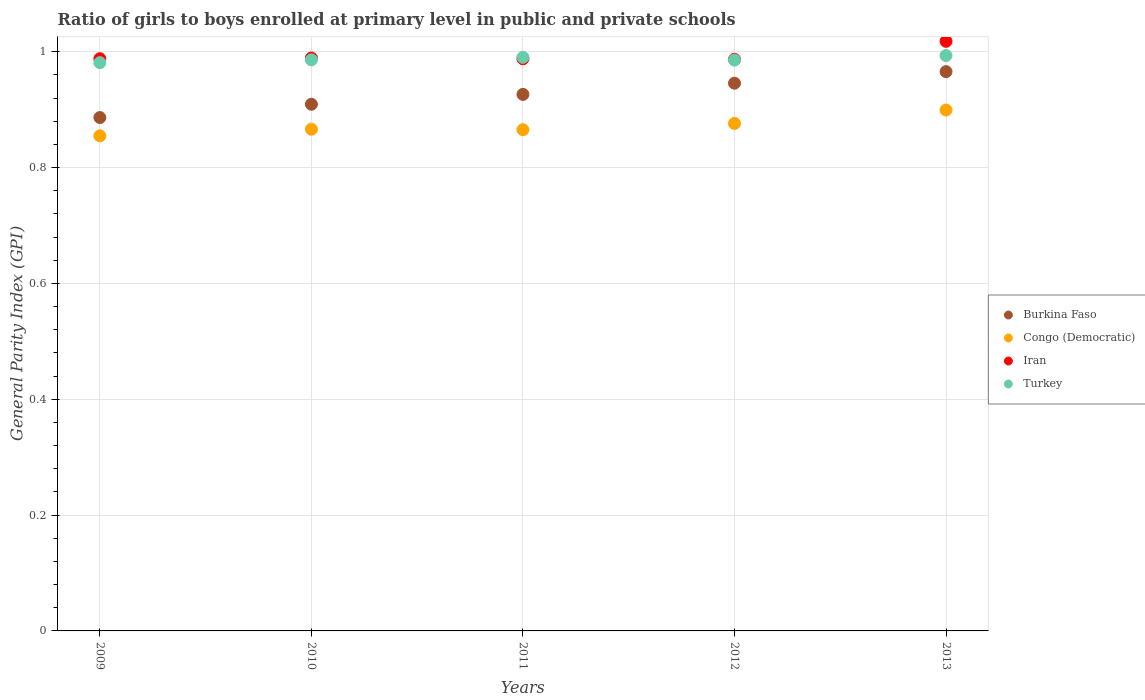How many different coloured dotlines are there?
Offer a very short reply. 4. Is the number of dotlines equal to the number of legend labels?
Provide a succinct answer. Yes. What is the general parity index in Congo (Democratic) in 2011?
Offer a terse response. 0.87. Across all years, what is the maximum general parity index in Turkey?
Your answer should be compact. 0.99. Across all years, what is the minimum general parity index in Burkina Faso?
Offer a terse response. 0.89. In which year was the general parity index in Congo (Democratic) maximum?
Offer a terse response. 2013. In which year was the general parity index in Congo (Democratic) minimum?
Your answer should be very brief. 2009. What is the total general parity index in Congo (Democratic) in the graph?
Offer a terse response. 4.36. What is the difference between the general parity index in Burkina Faso in 2010 and that in 2011?
Give a very brief answer. -0.02. What is the difference between the general parity index in Congo (Democratic) in 2013 and the general parity index in Burkina Faso in 2010?
Provide a succinct answer. -0.01. What is the average general parity index in Turkey per year?
Your answer should be very brief. 0.99. In the year 2012, what is the difference between the general parity index in Iran and general parity index in Burkina Faso?
Your response must be concise. 0.04. What is the ratio of the general parity index in Congo (Democratic) in 2009 to that in 2012?
Offer a very short reply. 0.98. Is the difference between the general parity index in Iran in 2011 and 2012 greater than the difference between the general parity index in Burkina Faso in 2011 and 2012?
Your answer should be compact. Yes. What is the difference between the highest and the second highest general parity index in Burkina Faso?
Your answer should be very brief. 0.02. What is the difference between the highest and the lowest general parity index in Turkey?
Your answer should be compact. 0.01. Is the sum of the general parity index in Iran in 2009 and 2010 greater than the maximum general parity index in Turkey across all years?
Make the answer very short. Yes. Is it the case that in every year, the sum of the general parity index in Turkey and general parity index in Burkina Faso  is greater than the sum of general parity index in Iran and general parity index in Congo (Democratic)?
Ensure brevity in your answer.  No. Is it the case that in every year, the sum of the general parity index in Iran and general parity index in Congo (Democratic)  is greater than the general parity index in Burkina Faso?
Your answer should be compact. Yes. Is the general parity index in Iran strictly greater than the general parity index in Burkina Faso over the years?
Ensure brevity in your answer.  Yes. Is the general parity index in Burkina Faso strictly less than the general parity index in Iran over the years?
Provide a succinct answer. Yes. How many dotlines are there?
Make the answer very short. 4. How many years are there in the graph?
Your response must be concise. 5. Does the graph contain any zero values?
Your response must be concise. No. Does the graph contain grids?
Your answer should be compact. Yes. How many legend labels are there?
Offer a terse response. 4. What is the title of the graph?
Give a very brief answer. Ratio of girls to boys enrolled at primary level in public and private schools. What is the label or title of the Y-axis?
Your answer should be compact. General Parity Index (GPI). What is the General Parity Index (GPI) of Burkina Faso in 2009?
Keep it short and to the point. 0.89. What is the General Parity Index (GPI) of Congo (Democratic) in 2009?
Your answer should be compact. 0.85. What is the General Parity Index (GPI) in Iran in 2009?
Offer a very short reply. 0.99. What is the General Parity Index (GPI) of Turkey in 2009?
Make the answer very short. 0.98. What is the General Parity Index (GPI) of Burkina Faso in 2010?
Make the answer very short. 0.91. What is the General Parity Index (GPI) of Congo (Democratic) in 2010?
Provide a succinct answer. 0.87. What is the General Parity Index (GPI) of Iran in 2010?
Your response must be concise. 0.99. What is the General Parity Index (GPI) in Turkey in 2010?
Keep it short and to the point. 0.99. What is the General Parity Index (GPI) in Burkina Faso in 2011?
Offer a very short reply. 0.93. What is the General Parity Index (GPI) of Congo (Democratic) in 2011?
Ensure brevity in your answer.  0.87. What is the General Parity Index (GPI) of Iran in 2011?
Provide a short and direct response. 0.99. What is the General Parity Index (GPI) in Turkey in 2011?
Offer a very short reply. 0.99. What is the General Parity Index (GPI) in Burkina Faso in 2012?
Your response must be concise. 0.95. What is the General Parity Index (GPI) in Congo (Democratic) in 2012?
Offer a very short reply. 0.88. What is the General Parity Index (GPI) of Iran in 2012?
Your answer should be very brief. 0.99. What is the General Parity Index (GPI) in Turkey in 2012?
Offer a terse response. 0.99. What is the General Parity Index (GPI) in Burkina Faso in 2013?
Provide a succinct answer. 0.97. What is the General Parity Index (GPI) in Congo (Democratic) in 2013?
Your response must be concise. 0.9. What is the General Parity Index (GPI) in Iran in 2013?
Offer a terse response. 1.02. What is the General Parity Index (GPI) in Turkey in 2013?
Keep it short and to the point. 0.99. Across all years, what is the maximum General Parity Index (GPI) of Burkina Faso?
Ensure brevity in your answer.  0.97. Across all years, what is the maximum General Parity Index (GPI) of Congo (Democratic)?
Provide a succinct answer. 0.9. Across all years, what is the maximum General Parity Index (GPI) in Iran?
Make the answer very short. 1.02. Across all years, what is the maximum General Parity Index (GPI) in Turkey?
Offer a very short reply. 0.99. Across all years, what is the minimum General Parity Index (GPI) in Burkina Faso?
Ensure brevity in your answer.  0.89. Across all years, what is the minimum General Parity Index (GPI) of Congo (Democratic)?
Your response must be concise. 0.85. Across all years, what is the minimum General Parity Index (GPI) in Iran?
Your answer should be very brief. 0.99. Across all years, what is the minimum General Parity Index (GPI) in Turkey?
Ensure brevity in your answer.  0.98. What is the total General Parity Index (GPI) of Burkina Faso in the graph?
Your response must be concise. 4.63. What is the total General Parity Index (GPI) of Congo (Democratic) in the graph?
Give a very brief answer. 4.36. What is the total General Parity Index (GPI) in Iran in the graph?
Your answer should be very brief. 4.97. What is the total General Parity Index (GPI) in Turkey in the graph?
Provide a short and direct response. 4.94. What is the difference between the General Parity Index (GPI) of Burkina Faso in 2009 and that in 2010?
Provide a short and direct response. -0.02. What is the difference between the General Parity Index (GPI) in Congo (Democratic) in 2009 and that in 2010?
Make the answer very short. -0.01. What is the difference between the General Parity Index (GPI) in Iran in 2009 and that in 2010?
Keep it short and to the point. -0. What is the difference between the General Parity Index (GPI) in Turkey in 2009 and that in 2010?
Provide a short and direct response. -0. What is the difference between the General Parity Index (GPI) in Burkina Faso in 2009 and that in 2011?
Offer a terse response. -0.04. What is the difference between the General Parity Index (GPI) in Congo (Democratic) in 2009 and that in 2011?
Your response must be concise. -0.01. What is the difference between the General Parity Index (GPI) of Turkey in 2009 and that in 2011?
Give a very brief answer. -0.01. What is the difference between the General Parity Index (GPI) of Burkina Faso in 2009 and that in 2012?
Make the answer very short. -0.06. What is the difference between the General Parity Index (GPI) of Congo (Democratic) in 2009 and that in 2012?
Your response must be concise. -0.02. What is the difference between the General Parity Index (GPI) in Iran in 2009 and that in 2012?
Offer a very short reply. 0. What is the difference between the General Parity Index (GPI) of Turkey in 2009 and that in 2012?
Make the answer very short. -0. What is the difference between the General Parity Index (GPI) of Burkina Faso in 2009 and that in 2013?
Ensure brevity in your answer.  -0.08. What is the difference between the General Parity Index (GPI) in Congo (Democratic) in 2009 and that in 2013?
Ensure brevity in your answer.  -0.04. What is the difference between the General Parity Index (GPI) in Iran in 2009 and that in 2013?
Ensure brevity in your answer.  -0.03. What is the difference between the General Parity Index (GPI) in Turkey in 2009 and that in 2013?
Your answer should be compact. -0.01. What is the difference between the General Parity Index (GPI) of Burkina Faso in 2010 and that in 2011?
Keep it short and to the point. -0.02. What is the difference between the General Parity Index (GPI) of Congo (Democratic) in 2010 and that in 2011?
Your response must be concise. 0. What is the difference between the General Parity Index (GPI) of Iran in 2010 and that in 2011?
Ensure brevity in your answer.  0. What is the difference between the General Parity Index (GPI) in Turkey in 2010 and that in 2011?
Offer a terse response. -0. What is the difference between the General Parity Index (GPI) in Burkina Faso in 2010 and that in 2012?
Provide a succinct answer. -0.04. What is the difference between the General Parity Index (GPI) of Congo (Democratic) in 2010 and that in 2012?
Provide a succinct answer. -0.01. What is the difference between the General Parity Index (GPI) of Iran in 2010 and that in 2012?
Your response must be concise. 0. What is the difference between the General Parity Index (GPI) in Burkina Faso in 2010 and that in 2013?
Provide a short and direct response. -0.06. What is the difference between the General Parity Index (GPI) of Congo (Democratic) in 2010 and that in 2013?
Provide a succinct answer. -0.03. What is the difference between the General Parity Index (GPI) in Iran in 2010 and that in 2013?
Ensure brevity in your answer.  -0.03. What is the difference between the General Parity Index (GPI) in Turkey in 2010 and that in 2013?
Provide a succinct answer. -0.01. What is the difference between the General Parity Index (GPI) in Burkina Faso in 2011 and that in 2012?
Make the answer very short. -0.02. What is the difference between the General Parity Index (GPI) of Congo (Democratic) in 2011 and that in 2012?
Provide a short and direct response. -0.01. What is the difference between the General Parity Index (GPI) in Iran in 2011 and that in 2012?
Your response must be concise. 0. What is the difference between the General Parity Index (GPI) in Turkey in 2011 and that in 2012?
Ensure brevity in your answer.  0. What is the difference between the General Parity Index (GPI) in Burkina Faso in 2011 and that in 2013?
Your answer should be very brief. -0.04. What is the difference between the General Parity Index (GPI) in Congo (Democratic) in 2011 and that in 2013?
Provide a short and direct response. -0.03. What is the difference between the General Parity Index (GPI) in Iran in 2011 and that in 2013?
Give a very brief answer. -0.03. What is the difference between the General Parity Index (GPI) of Turkey in 2011 and that in 2013?
Your answer should be very brief. -0. What is the difference between the General Parity Index (GPI) of Burkina Faso in 2012 and that in 2013?
Ensure brevity in your answer.  -0.02. What is the difference between the General Parity Index (GPI) in Congo (Democratic) in 2012 and that in 2013?
Give a very brief answer. -0.02. What is the difference between the General Parity Index (GPI) in Iran in 2012 and that in 2013?
Give a very brief answer. -0.03. What is the difference between the General Parity Index (GPI) of Turkey in 2012 and that in 2013?
Offer a terse response. -0.01. What is the difference between the General Parity Index (GPI) of Burkina Faso in 2009 and the General Parity Index (GPI) of Congo (Democratic) in 2010?
Your answer should be very brief. 0.02. What is the difference between the General Parity Index (GPI) in Burkina Faso in 2009 and the General Parity Index (GPI) in Iran in 2010?
Make the answer very short. -0.1. What is the difference between the General Parity Index (GPI) of Burkina Faso in 2009 and the General Parity Index (GPI) of Turkey in 2010?
Your answer should be very brief. -0.1. What is the difference between the General Parity Index (GPI) in Congo (Democratic) in 2009 and the General Parity Index (GPI) in Iran in 2010?
Your answer should be compact. -0.13. What is the difference between the General Parity Index (GPI) in Congo (Democratic) in 2009 and the General Parity Index (GPI) in Turkey in 2010?
Your answer should be very brief. -0.13. What is the difference between the General Parity Index (GPI) of Iran in 2009 and the General Parity Index (GPI) of Turkey in 2010?
Ensure brevity in your answer.  0. What is the difference between the General Parity Index (GPI) of Burkina Faso in 2009 and the General Parity Index (GPI) of Congo (Democratic) in 2011?
Give a very brief answer. 0.02. What is the difference between the General Parity Index (GPI) in Burkina Faso in 2009 and the General Parity Index (GPI) in Iran in 2011?
Offer a terse response. -0.1. What is the difference between the General Parity Index (GPI) of Burkina Faso in 2009 and the General Parity Index (GPI) of Turkey in 2011?
Give a very brief answer. -0.1. What is the difference between the General Parity Index (GPI) of Congo (Democratic) in 2009 and the General Parity Index (GPI) of Iran in 2011?
Give a very brief answer. -0.13. What is the difference between the General Parity Index (GPI) in Congo (Democratic) in 2009 and the General Parity Index (GPI) in Turkey in 2011?
Ensure brevity in your answer.  -0.14. What is the difference between the General Parity Index (GPI) in Iran in 2009 and the General Parity Index (GPI) in Turkey in 2011?
Offer a terse response. -0. What is the difference between the General Parity Index (GPI) of Burkina Faso in 2009 and the General Parity Index (GPI) of Congo (Democratic) in 2012?
Your response must be concise. 0.01. What is the difference between the General Parity Index (GPI) of Burkina Faso in 2009 and the General Parity Index (GPI) of Iran in 2012?
Provide a short and direct response. -0.1. What is the difference between the General Parity Index (GPI) in Burkina Faso in 2009 and the General Parity Index (GPI) in Turkey in 2012?
Keep it short and to the point. -0.1. What is the difference between the General Parity Index (GPI) in Congo (Democratic) in 2009 and the General Parity Index (GPI) in Iran in 2012?
Your answer should be compact. -0.13. What is the difference between the General Parity Index (GPI) of Congo (Democratic) in 2009 and the General Parity Index (GPI) of Turkey in 2012?
Provide a succinct answer. -0.13. What is the difference between the General Parity Index (GPI) in Iran in 2009 and the General Parity Index (GPI) in Turkey in 2012?
Offer a terse response. 0. What is the difference between the General Parity Index (GPI) in Burkina Faso in 2009 and the General Parity Index (GPI) in Congo (Democratic) in 2013?
Make the answer very short. -0.01. What is the difference between the General Parity Index (GPI) of Burkina Faso in 2009 and the General Parity Index (GPI) of Iran in 2013?
Provide a succinct answer. -0.13. What is the difference between the General Parity Index (GPI) in Burkina Faso in 2009 and the General Parity Index (GPI) in Turkey in 2013?
Make the answer very short. -0.11. What is the difference between the General Parity Index (GPI) in Congo (Democratic) in 2009 and the General Parity Index (GPI) in Iran in 2013?
Keep it short and to the point. -0.16. What is the difference between the General Parity Index (GPI) in Congo (Democratic) in 2009 and the General Parity Index (GPI) in Turkey in 2013?
Provide a short and direct response. -0.14. What is the difference between the General Parity Index (GPI) of Iran in 2009 and the General Parity Index (GPI) of Turkey in 2013?
Offer a terse response. -0.01. What is the difference between the General Parity Index (GPI) of Burkina Faso in 2010 and the General Parity Index (GPI) of Congo (Democratic) in 2011?
Offer a very short reply. 0.04. What is the difference between the General Parity Index (GPI) of Burkina Faso in 2010 and the General Parity Index (GPI) of Iran in 2011?
Your response must be concise. -0.08. What is the difference between the General Parity Index (GPI) of Burkina Faso in 2010 and the General Parity Index (GPI) of Turkey in 2011?
Provide a succinct answer. -0.08. What is the difference between the General Parity Index (GPI) of Congo (Democratic) in 2010 and the General Parity Index (GPI) of Iran in 2011?
Your answer should be compact. -0.12. What is the difference between the General Parity Index (GPI) in Congo (Democratic) in 2010 and the General Parity Index (GPI) in Turkey in 2011?
Make the answer very short. -0.12. What is the difference between the General Parity Index (GPI) in Iran in 2010 and the General Parity Index (GPI) in Turkey in 2011?
Ensure brevity in your answer.  -0. What is the difference between the General Parity Index (GPI) of Burkina Faso in 2010 and the General Parity Index (GPI) of Congo (Democratic) in 2012?
Your answer should be very brief. 0.03. What is the difference between the General Parity Index (GPI) in Burkina Faso in 2010 and the General Parity Index (GPI) in Iran in 2012?
Ensure brevity in your answer.  -0.08. What is the difference between the General Parity Index (GPI) of Burkina Faso in 2010 and the General Parity Index (GPI) of Turkey in 2012?
Make the answer very short. -0.08. What is the difference between the General Parity Index (GPI) of Congo (Democratic) in 2010 and the General Parity Index (GPI) of Iran in 2012?
Ensure brevity in your answer.  -0.12. What is the difference between the General Parity Index (GPI) in Congo (Democratic) in 2010 and the General Parity Index (GPI) in Turkey in 2012?
Your answer should be compact. -0.12. What is the difference between the General Parity Index (GPI) of Iran in 2010 and the General Parity Index (GPI) of Turkey in 2012?
Provide a short and direct response. 0. What is the difference between the General Parity Index (GPI) in Burkina Faso in 2010 and the General Parity Index (GPI) in Congo (Democratic) in 2013?
Offer a very short reply. 0.01. What is the difference between the General Parity Index (GPI) in Burkina Faso in 2010 and the General Parity Index (GPI) in Iran in 2013?
Offer a terse response. -0.11. What is the difference between the General Parity Index (GPI) in Burkina Faso in 2010 and the General Parity Index (GPI) in Turkey in 2013?
Your answer should be compact. -0.08. What is the difference between the General Parity Index (GPI) of Congo (Democratic) in 2010 and the General Parity Index (GPI) of Iran in 2013?
Your answer should be compact. -0.15. What is the difference between the General Parity Index (GPI) in Congo (Democratic) in 2010 and the General Parity Index (GPI) in Turkey in 2013?
Ensure brevity in your answer.  -0.13. What is the difference between the General Parity Index (GPI) of Iran in 2010 and the General Parity Index (GPI) of Turkey in 2013?
Offer a very short reply. -0. What is the difference between the General Parity Index (GPI) in Burkina Faso in 2011 and the General Parity Index (GPI) in Congo (Democratic) in 2012?
Provide a short and direct response. 0.05. What is the difference between the General Parity Index (GPI) of Burkina Faso in 2011 and the General Parity Index (GPI) of Iran in 2012?
Ensure brevity in your answer.  -0.06. What is the difference between the General Parity Index (GPI) of Burkina Faso in 2011 and the General Parity Index (GPI) of Turkey in 2012?
Ensure brevity in your answer.  -0.06. What is the difference between the General Parity Index (GPI) in Congo (Democratic) in 2011 and the General Parity Index (GPI) in Iran in 2012?
Provide a succinct answer. -0.12. What is the difference between the General Parity Index (GPI) in Congo (Democratic) in 2011 and the General Parity Index (GPI) in Turkey in 2012?
Offer a very short reply. -0.12. What is the difference between the General Parity Index (GPI) in Iran in 2011 and the General Parity Index (GPI) in Turkey in 2012?
Offer a very short reply. 0. What is the difference between the General Parity Index (GPI) in Burkina Faso in 2011 and the General Parity Index (GPI) in Congo (Democratic) in 2013?
Give a very brief answer. 0.03. What is the difference between the General Parity Index (GPI) of Burkina Faso in 2011 and the General Parity Index (GPI) of Iran in 2013?
Offer a very short reply. -0.09. What is the difference between the General Parity Index (GPI) of Burkina Faso in 2011 and the General Parity Index (GPI) of Turkey in 2013?
Provide a succinct answer. -0.07. What is the difference between the General Parity Index (GPI) of Congo (Democratic) in 2011 and the General Parity Index (GPI) of Iran in 2013?
Your response must be concise. -0.15. What is the difference between the General Parity Index (GPI) of Congo (Democratic) in 2011 and the General Parity Index (GPI) of Turkey in 2013?
Your answer should be compact. -0.13. What is the difference between the General Parity Index (GPI) in Iran in 2011 and the General Parity Index (GPI) in Turkey in 2013?
Offer a terse response. -0.01. What is the difference between the General Parity Index (GPI) in Burkina Faso in 2012 and the General Parity Index (GPI) in Congo (Democratic) in 2013?
Provide a short and direct response. 0.05. What is the difference between the General Parity Index (GPI) in Burkina Faso in 2012 and the General Parity Index (GPI) in Iran in 2013?
Your answer should be compact. -0.07. What is the difference between the General Parity Index (GPI) in Burkina Faso in 2012 and the General Parity Index (GPI) in Turkey in 2013?
Give a very brief answer. -0.05. What is the difference between the General Parity Index (GPI) of Congo (Democratic) in 2012 and the General Parity Index (GPI) of Iran in 2013?
Keep it short and to the point. -0.14. What is the difference between the General Parity Index (GPI) in Congo (Democratic) in 2012 and the General Parity Index (GPI) in Turkey in 2013?
Provide a short and direct response. -0.12. What is the difference between the General Parity Index (GPI) in Iran in 2012 and the General Parity Index (GPI) in Turkey in 2013?
Give a very brief answer. -0.01. What is the average General Parity Index (GPI) of Burkina Faso per year?
Offer a terse response. 0.93. What is the average General Parity Index (GPI) in Congo (Democratic) per year?
Make the answer very short. 0.87. What is the average General Parity Index (GPI) of Iran per year?
Make the answer very short. 0.99. What is the average General Parity Index (GPI) in Turkey per year?
Provide a short and direct response. 0.99. In the year 2009, what is the difference between the General Parity Index (GPI) in Burkina Faso and General Parity Index (GPI) in Congo (Democratic)?
Give a very brief answer. 0.03. In the year 2009, what is the difference between the General Parity Index (GPI) in Burkina Faso and General Parity Index (GPI) in Iran?
Offer a terse response. -0.1. In the year 2009, what is the difference between the General Parity Index (GPI) of Burkina Faso and General Parity Index (GPI) of Turkey?
Your answer should be compact. -0.09. In the year 2009, what is the difference between the General Parity Index (GPI) in Congo (Democratic) and General Parity Index (GPI) in Iran?
Your answer should be compact. -0.13. In the year 2009, what is the difference between the General Parity Index (GPI) of Congo (Democratic) and General Parity Index (GPI) of Turkey?
Ensure brevity in your answer.  -0.13. In the year 2009, what is the difference between the General Parity Index (GPI) in Iran and General Parity Index (GPI) in Turkey?
Keep it short and to the point. 0.01. In the year 2010, what is the difference between the General Parity Index (GPI) in Burkina Faso and General Parity Index (GPI) in Congo (Democratic)?
Make the answer very short. 0.04. In the year 2010, what is the difference between the General Parity Index (GPI) in Burkina Faso and General Parity Index (GPI) in Iran?
Offer a very short reply. -0.08. In the year 2010, what is the difference between the General Parity Index (GPI) of Burkina Faso and General Parity Index (GPI) of Turkey?
Your answer should be very brief. -0.08. In the year 2010, what is the difference between the General Parity Index (GPI) in Congo (Democratic) and General Parity Index (GPI) in Iran?
Provide a succinct answer. -0.12. In the year 2010, what is the difference between the General Parity Index (GPI) in Congo (Democratic) and General Parity Index (GPI) in Turkey?
Keep it short and to the point. -0.12. In the year 2010, what is the difference between the General Parity Index (GPI) of Iran and General Parity Index (GPI) of Turkey?
Ensure brevity in your answer.  0. In the year 2011, what is the difference between the General Parity Index (GPI) of Burkina Faso and General Parity Index (GPI) of Congo (Democratic)?
Your response must be concise. 0.06. In the year 2011, what is the difference between the General Parity Index (GPI) of Burkina Faso and General Parity Index (GPI) of Iran?
Give a very brief answer. -0.06. In the year 2011, what is the difference between the General Parity Index (GPI) in Burkina Faso and General Parity Index (GPI) in Turkey?
Offer a very short reply. -0.06. In the year 2011, what is the difference between the General Parity Index (GPI) in Congo (Democratic) and General Parity Index (GPI) in Iran?
Provide a succinct answer. -0.12. In the year 2011, what is the difference between the General Parity Index (GPI) of Congo (Democratic) and General Parity Index (GPI) of Turkey?
Ensure brevity in your answer.  -0.12. In the year 2011, what is the difference between the General Parity Index (GPI) in Iran and General Parity Index (GPI) in Turkey?
Keep it short and to the point. -0. In the year 2012, what is the difference between the General Parity Index (GPI) of Burkina Faso and General Parity Index (GPI) of Congo (Democratic)?
Offer a terse response. 0.07. In the year 2012, what is the difference between the General Parity Index (GPI) of Burkina Faso and General Parity Index (GPI) of Iran?
Offer a terse response. -0.04. In the year 2012, what is the difference between the General Parity Index (GPI) in Burkina Faso and General Parity Index (GPI) in Turkey?
Offer a very short reply. -0.04. In the year 2012, what is the difference between the General Parity Index (GPI) of Congo (Democratic) and General Parity Index (GPI) of Iran?
Offer a terse response. -0.11. In the year 2012, what is the difference between the General Parity Index (GPI) in Congo (Democratic) and General Parity Index (GPI) in Turkey?
Your answer should be compact. -0.11. In the year 2012, what is the difference between the General Parity Index (GPI) in Iran and General Parity Index (GPI) in Turkey?
Offer a terse response. 0. In the year 2013, what is the difference between the General Parity Index (GPI) of Burkina Faso and General Parity Index (GPI) of Congo (Democratic)?
Offer a terse response. 0.07. In the year 2013, what is the difference between the General Parity Index (GPI) of Burkina Faso and General Parity Index (GPI) of Iran?
Give a very brief answer. -0.05. In the year 2013, what is the difference between the General Parity Index (GPI) of Burkina Faso and General Parity Index (GPI) of Turkey?
Provide a succinct answer. -0.03. In the year 2013, what is the difference between the General Parity Index (GPI) of Congo (Democratic) and General Parity Index (GPI) of Iran?
Offer a very short reply. -0.12. In the year 2013, what is the difference between the General Parity Index (GPI) in Congo (Democratic) and General Parity Index (GPI) in Turkey?
Keep it short and to the point. -0.09. In the year 2013, what is the difference between the General Parity Index (GPI) in Iran and General Parity Index (GPI) in Turkey?
Offer a very short reply. 0.02. What is the ratio of the General Parity Index (GPI) in Burkina Faso in 2009 to that in 2010?
Make the answer very short. 0.97. What is the ratio of the General Parity Index (GPI) in Congo (Democratic) in 2009 to that in 2010?
Make the answer very short. 0.99. What is the ratio of the General Parity Index (GPI) in Iran in 2009 to that in 2010?
Give a very brief answer. 1. What is the ratio of the General Parity Index (GPI) in Burkina Faso in 2009 to that in 2011?
Provide a short and direct response. 0.96. What is the ratio of the General Parity Index (GPI) of Iran in 2009 to that in 2011?
Ensure brevity in your answer.  1. What is the ratio of the General Parity Index (GPI) of Turkey in 2009 to that in 2011?
Ensure brevity in your answer.  0.99. What is the ratio of the General Parity Index (GPI) in Burkina Faso in 2009 to that in 2012?
Your answer should be compact. 0.94. What is the ratio of the General Parity Index (GPI) in Congo (Democratic) in 2009 to that in 2012?
Offer a terse response. 0.98. What is the ratio of the General Parity Index (GPI) of Burkina Faso in 2009 to that in 2013?
Provide a succinct answer. 0.92. What is the ratio of the General Parity Index (GPI) of Congo (Democratic) in 2009 to that in 2013?
Keep it short and to the point. 0.95. What is the ratio of the General Parity Index (GPI) in Iran in 2009 to that in 2013?
Your answer should be compact. 0.97. What is the ratio of the General Parity Index (GPI) in Burkina Faso in 2010 to that in 2011?
Give a very brief answer. 0.98. What is the ratio of the General Parity Index (GPI) in Burkina Faso in 2010 to that in 2012?
Offer a very short reply. 0.96. What is the ratio of the General Parity Index (GPI) of Congo (Democratic) in 2010 to that in 2012?
Your response must be concise. 0.99. What is the ratio of the General Parity Index (GPI) in Turkey in 2010 to that in 2012?
Make the answer very short. 1. What is the ratio of the General Parity Index (GPI) of Burkina Faso in 2010 to that in 2013?
Make the answer very short. 0.94. What is the ratio of the General Parity Index (GPI) of Congo (Democratic) in 2010 to that in 2013?
Your answer should be compact. 0.96. What is the ratio of the General Parity Index (GPI) in Iran in 2010 to that in 2013?
Your response must be concise. 0.97. What is the ratio of the General Parity Index (GPI) in Burkina Faso in 2011 to that in 2012?
Offer a terse response. 0.98. What is the ratio of the General Parity Index (GPI) of Congo (Democratic) in 2011 to that in 2012?
Provide a short and direct response. 0.99. What is the ratio of the General Parity Index (GPI) of Iran in 2011 to that in 2012?
Provide a succinct answer. 1. What is the ratio of the General Parity Index (GPI) in Burkina Faso in 2011 to that in 2013?
Offer a terse response. 0.96. What is the ratio of the General Parity Index (GPI) of Congo (Democratic) in 2011 to that in 2013?
Ensure brevity in your answer.  0.96. What is the ratio of the General Parity Index (GPI) in Iran in 2011 to that in 2013?
Ensure brevity in your answer.  0.97. What is the ratio of the General Parity Index (GPI) of Turkey in 2011 to that in 2013?
Provide a succinct answer. 1. What is the ratio of the General Parity Index (GPI) in Burkina Faso in 2012 to that in 2013?
Provide a succinct answer. 0.98. What is the ratio of the General Parity Index (GPI) of Congo (Democratic) in 2012 to that in 2013?
Give a very brief answer. 0.97. What is the ratio of the General Parity Index (GPI) of Iran in 2012 to that in 2013?
Keep it short and to the point. 0.97. What is the difference between the highest and the second highest General Parity Index (GPI) of Burkina Faso?
Keep it short and to the point. 0.02. What is the difference between the highest and the second highest General Parity Index (GPI) in Congo (Democratic)?
Ensure brevity in your answer.  0.02. What is the difference between the highest and the second highest General Parity Index (GPI) in Iran?
Your answer should be compact. 0.03. What is the difference between the highest and the second highest General Parity Index (GPI) of Turkey?
Your answer should be very brief. 0. What is the difference between the highest and the lowest General Parity Index (GPI) in Burkina Faso?
Make the answer very short. 0.08. What is the difference between the highest and the lowest General Parity Index (GPI) in Congo (Democratic)?
Your response must be concise. 0.04. What is the difference between the highest and the lowest General Parity Index (GPI) of Iran?
Offer a very short reply. 0.03. What is the difference between the highest and the lowest General Parity Index (GPI) in Turkey?
Make the answer very short. 0.01. 